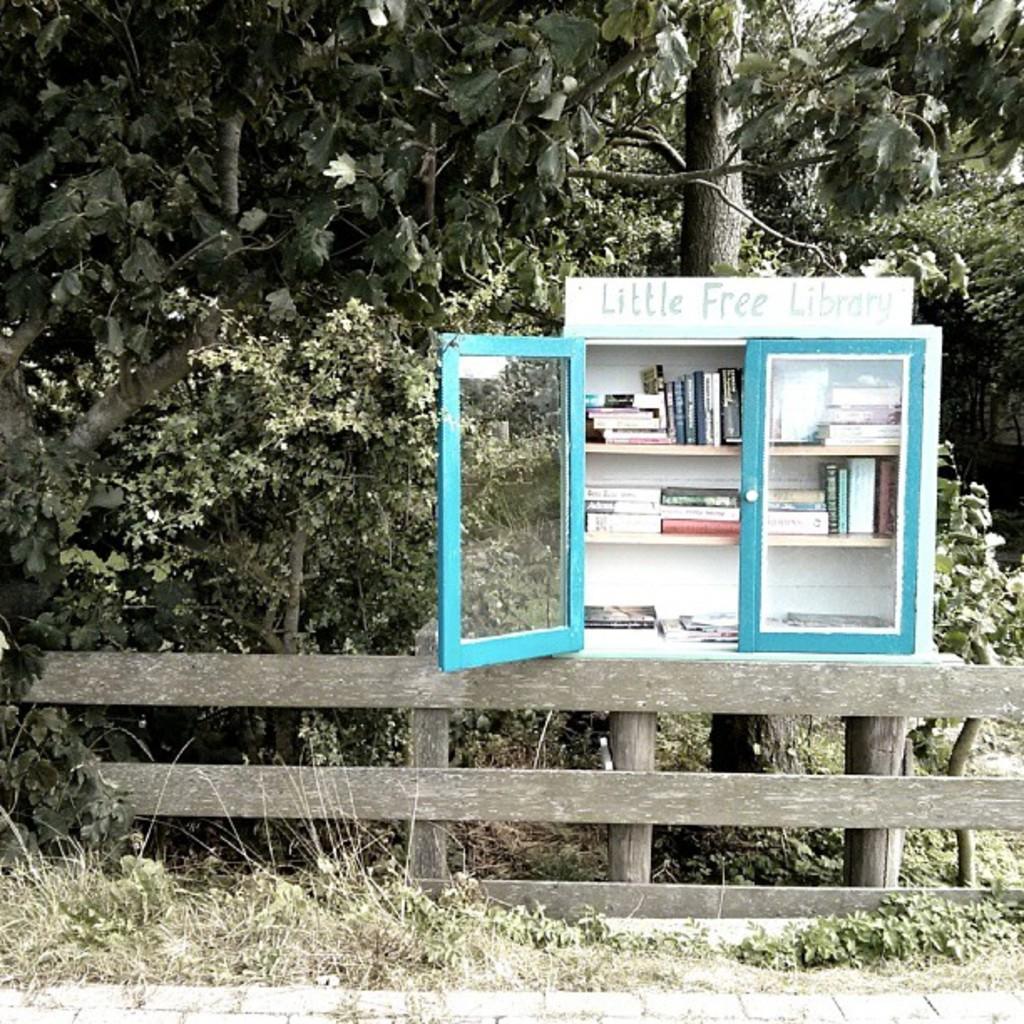How much does it cost?
Keep it short and to the point. Free. 